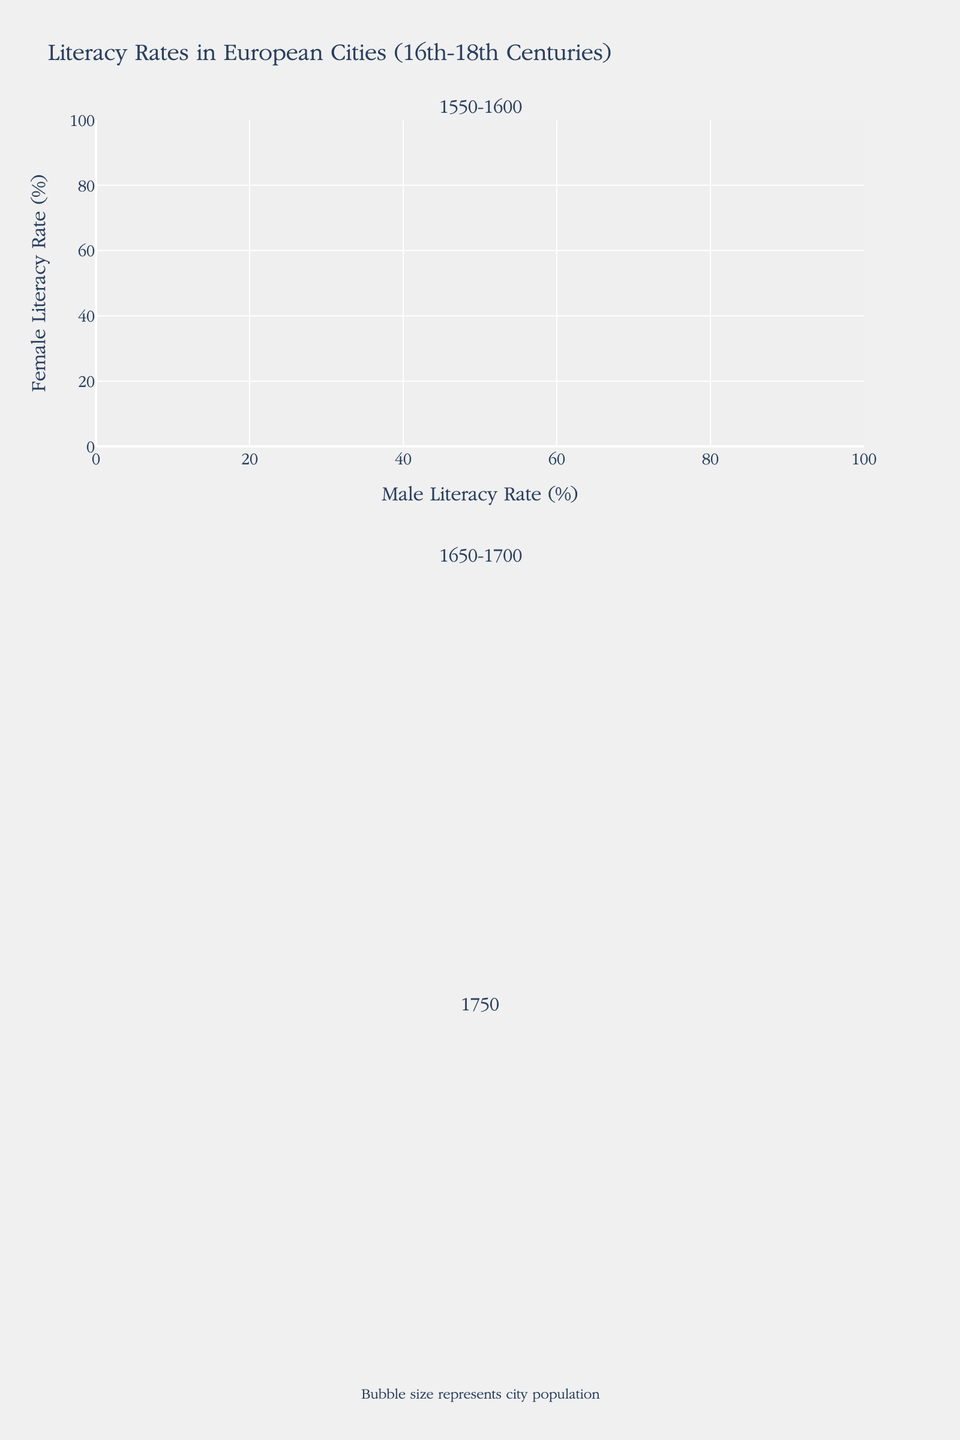What is the title of the plot? The title is located at the top center of the plot and summarizes the main topic. It often contains descriptive text about the content of the figure.
Answer: Literacy Rates in European Cities (16th-18th Centuries) What do the axes represent? The axes are labeled at their ends. The x-axis represents the Male Literacy Rate (%), and the y-axis represents the Female Literacy Rate (%).
Answer: Male Literacy Rate (%) and Female Literacy Rate (%) Which city shows the highest male literacy rate in 1550? By looking at the bubbles in the 1550-1600 subplot, we can see that Venice has the highest male literacy rate since the bubble for Venice is the furthest right in that subplot.
Answer: Venice Which city has the largest population in 1750? To determine the city with the largest population, we examine the sizes of bubbles in the 1750 subplot. The largest bubble represents London.
Answer: London What is the relationship between male and female literacy rates in Amsterdam in 1750? We locate Amsterdam in the 1750 subplot and observe its position relative to both axes. Amsterdam shows a male literacy rate of 75% and a female literacy rate of 50%.
Answer: Male literacy rate is higher than female literacy rate Which city had a significant increase in female literacy from 1550 to 1650? By comparing the position of the same city's bubbles between the 1550-1600 and 1650-1700 subplots, we see that London had a significant increase in female literacy from 8% in 1550 to 25% in 1650.
Answer: London Compare male literacy rates in Paris and London in 1650. Which is higher? Checking the 1650-1700 subplot, we see Paris at around 38% for male literacy and London at about 45%. Therefore, London has a higher male literacy rate.
Answer: London What is the trend in female literacy rates in Amsterdam from 1600 to 1750? Observing the plots for each period, female literacy in Amsterdam rises from 15% in 1600 to 30% in 1650 and reaches 50% by 1750, indicating a continuous increase.
Answer: Increasing trend Are there any cities where female literacy surpasses 40% in 1750? Looking at the 1750 subplot, we see that Amsterdam and London are the only cities with female literacy rates above 40%.
Answer: Yes What can be inferred about the growth in population size in London from 1550 to 1750? By comparing the bubble sizes for London across the three subplots, one can observe the increase in size, indicating population growth. From smaller in 1550 to significantly larger in 1750.
Answer: Population increased 